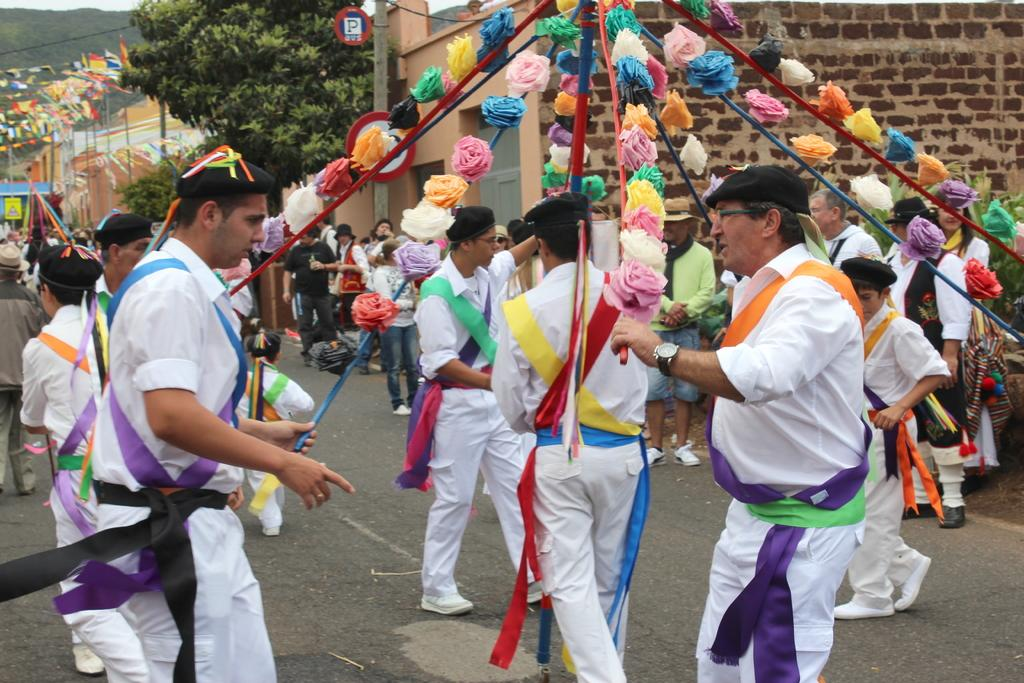Who or what can be seen in the image? There are people, flowers, houses, and a tree in the image. What are the people wearing in the image? Some people in the front are wearing white color dresses. Can you describe the setting of the image? The image features people, flowers, houses, and a tree, which suggests a residential or community area. Are there any zebras wearing masks in the image? No, there are no zebras or masks present in the image. What act are the people in the image performing? The image does not depict any specific act or activity being performed by the people. 